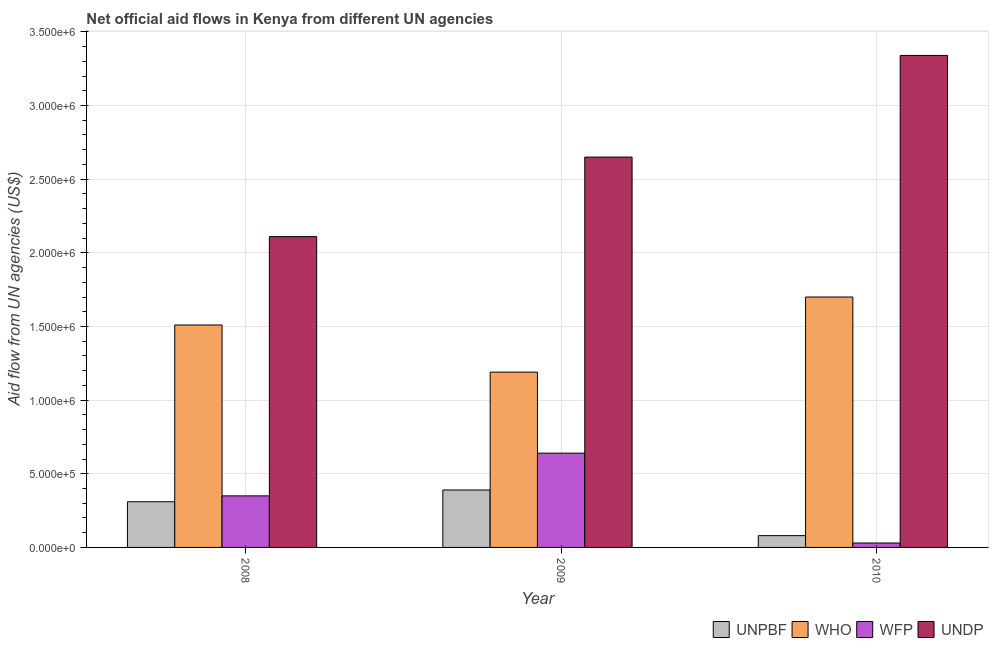How many different coloured bars are there?
Keep it short and to the point. 4. How many groups of bars are there?
Provide a short and direct response. 3. Are the number of bars per tick equal to the number of legend labels?
Make the answer very short. Yes. Are the number of bars on each tick of the X-axis equal?
Ensure brevity in your answer.  Yes. What is the amount of aid given by unpbf in 2010?
Provide a succinct answer. 8.00e+04. Across all years, what is the maximum amount of aid given by wfp?
Your response must be concise. 6.40e+05. Across all years, what is the minimum amount of aid given by unpbf?
Ensure brevity in your answer.  8.00e+04. In which year was the amount of aid given by unpbf minimum?
Your answer should be compact. 2010. What is the total amount of aid given by who in the graph?
Provide a succinct answer. 4.40e+06. What is the difference between the amount of aid given by wfp in 2009 and that in 2010?
Offer a terse response. 6.10e+05. What is the difference between the amount of aid given by who in 2008 and the amount of aid given by wfp in 2010?
Provide a short and direct response. -1.90e+05. What is the average amount of aid given by wfp per year?
Provide a succinct answer. 3.40e+05. In how many years, is the amount of aid given by who greater than 3100000 US$?
Offer a very short reply. 0. What is the ratio of the amount of aid given by undp in 2009 to that in 2010?
Offer a terse response. 0.79. What is the difference between the highest and the lowest amount of aid given by unpbf?
Your answer should be compact. 3.10e+05. What does the 3rd bar from the left in 2010 represents?
Give a very brief answer. WFP. What does the 3rd bar from the right in 2010 represents?
Provide a succinct answer. WHO. Is it the case that in every year, the sum of the amount of aid given by unpbf and amount of aid given by who is greater than the amount of aid given by wfp?
Offer a very short reply. Yes. What is the difference between two consecutive major ticks on the Y-axis?
Provide a short and direct response. 5.00e+05. Are the values on the major ticks of Y-axis written in scientific E-notation?
Your answer should be very brief. Yes. Where does the legend appear in the graph?
Give a very brief answer. Bottom right. How are the legend labels stacked?
Ensure brevity in your answer.  Horizontal. What is the title of the graph?
Give a very brief answer. Net official aid flows in Kenya from different UN agencies. What is the label or title of the Y-axis?
Your response must be concise. Aid flow from UN agencies (US$). What is the Aid flow from UN agencies (US$) of WHO in 2008?
Offer a terse response. 1.51e+06. What is the Aid flow from UN agencies (US$) in UNDP in 2008?
Ensure brevity in your answer.  2.11e+06. What is the Aid flow from UN agencies (US$) in WHO in 2009?
Your answer should be compact. 1.19e+06. What is the Aid flow from UN agencies (US$) of WFP in 2009?
Provide a succinct answer. 6.40e+05. What is the Aid flow from UN agencies (US$) in UNDP in 2009?
Offer a very short reply. 2.65e+06. What is the Aid flow from UN agencies (US$) of UNPBF in 2010?
Your response must be concise. 8.00e+04. What is the Aid flow from UN agencies (US$) of WHO in 2010?
Provide a short and direct response. 1.70e+06. What is the Aid flow from UN agencies (US$) in UNDP in 2010?
Your answer should be compact. 3.34e+06. Across all years, what is the maximum Aid flow from UN agencies (US$) in UNPBF?
Your answer should be very brief. 3.90e+05. Across all years, what is the maximum Aid flow from UN agencies (US$) of WHO?
Offer a terse response. 1.70e+06. Across all years, what is the maximum Aid flow from UN agencies (US$) in WFP?
Make the answer very short. 6.40e+05. Across all years, what is the maximum Aid flow from UN agencies (US$) of UNDP?
Your response must be concise. 3.34e+06. Across all years, what is the minimum Aid flow from UN agencies (US$) in UNPBF?
Offer a terse response. 8.00e+04. Across all years, what is the minimum Aid flow from UN agencies (US$) of WHO?
Offer a terse response. 1.19e+06. Across all years, what is the minimum Aid flow from UN agencies (US$) of UNDP?
Your response must be concise. 2.11e+06. What is the total Aid flow from UN agencies (US$) in UNPBF in the graph?
Give a very brief answer. 7.80e+05. What is the total Aid flow from UN agencies (US$) of WHO in the graph?
Make the answer very short. 4.40e+06. What is the total Aid flow from UN agencies (US$) in WFP in the graph?
Provide a short and direct response. 1.02e+06. What is the total Aid flow from UN agencies (US$) in UNDP in the graph?
Give a very brief answer. 8.10e+06. What is the difference between the Aid flow from UN agencies (US$) in UNPBF in 2008 and that in 2009?
Make the answer very short. -8.00e+04. What is the difference between the Aid flow from UN agencies (US$) in WHO in 2008 and that in 2009?
Make the answer very short. 3.20e+05. What is the difference between the Aid flow from UN agencies (US$) in UNDP in 2008 and that in 2009?
Provide a short and direct response. -5.40e+05. What is the difference between the Aid flow from UN agencies (US$) of UNPBF in 2008 and that in 2010?
Provide a short and direct response. 2.30e+05. What is the difference between the Aid flow from UN agencies (US$) in UNDP in 2008 and that in 2010?
Provide a short and direct response. -1.23e+06. What is the difference between the Aid flow from UN agencies (US$) of UNPBF in 2009 and that in 2010?
Keep it short and to the point. 3.10e+05. What is the difference between the Aid flow from UN agencies (US$) of WHO in 2009 and that in 2010?
Your response must be concise. -5.10e+05. What is the difference between the Aid flow from UN agencies (US$) in WFP in 2009 and that in 2010?
Provide a succinct answer. 6.10e+05. What is the difference between the Aid flow from UN agencies (US$) in UNDP in 2009 and that in 2010?
Provide a succinct answer. -6.90e+05. What is the difference between the Aid flow from UN agencies (US$) of UNPBF in 2008 and the Aid flow from UN agencies (US$) of WHO in 2009?
Ensure brevity in your answer.  -8.80e+05. What is the difference between the Aid flow from UN agencies (US$) in UNPBF in 2008 and the Aid flow from UN agencies (US$) in WFP in 2009?
Your answer should be compact. -3.30e+05. What is the difference between the Aid flow from UN agencies (US$) of UNPBF in 2008 and the Aid flow from UN agencies (US$) of UNDP in 2009?
Provide a succinct answer. -2.34e+06. What is the difference between the Aid flow from UN agencies (US$) in WHO in 2008 and the Aid flow from UN agencies (US$) in WFP in 2009?
Make the answer very short. 8.70e+05. What is the difference between the Aid flow from UN agencies (US$) of WHO in 2008 and the Aid flow from UN agencies (US$) of UNDP in 2009?
Provide a short and direct response. -1.14e+06. What is the difference between the Aid flow from UN agencies (US$) in WFP in 2008 and the Aid flow from UN agencies (US$) in UNDP in 2009?
Your response must be concise. -2.30e+06. What is the difference between the Aid flow from UN agencies (US$) in UNPBF in 2008 and the Aid flow from UN agencies (US$) in WHO in 2010?
Provide a short and direct response. -1.39e+06. What is the difference between the Aid flow from UN agencies (US$) of UNPBF in 2008 and the Aid flow from UN agencies (US$) of WFP in 2010?
Offer a very short reply. 2.80e+05. What is the difference between the Aid flow from UN agencies (US$) of UNPBF in 2008 and the Aid flow from UN agencies (US$) of UNDP in 2010?
Keep it short and to the point. -3.03e+06. What is the difference between the Aid flow from UN agencies (US$) in WHO in 2008 and the Aid flow from UN agencies (US$) in WFP in 2010?
Provide a succinct answer. 1.48e+06. What is the difference between the Aid flow from UN agencies (US$) in WHO in 2008 and the Aid flow from UN agencies (US$) in UNDP in 2010?
Offer a very short reply. -1.83e+06. What is the difference between the Aid flow from UN agencies (US$) of WFP in 2008 and the Aid flow from UN agencies (US$) of UNDP in 2010?
Your answer should be very brief. -2.99e+06. What is the difference between the Aid flow from UN agencies (US$) in UNPBF in 2009 and the Aid flow from UN agencies (US$) in WHO in 2010?
Offer a terse response. -1.31e+06. What is the difference between the Aid flow from UN agencies (US$) in UNPBF in 2009 and the Aid flow from UN agencies (US$) in UNDP in 2010?
Provide a succinct answer. -2.95e+06. What is the difference between the Aid flow from UN agencies (US$) of WHO in 2009 and the Aid flow from UN agencies (US$) of WFP in 2010?
Your answer should be compact. 1.16e+06. What is the difference between the Aid flow from UN agencies (US$) in WHO in 2009 and the Aid flow from UN agencies (US$) in UNDP in 2010?
Offer a terse response. -2.15e+06. What is the difference between the Aid flow from UN agencies (US$) of WFP in 2009 and the Aid flow from UN agencies (US$) of UNDP in 2010?
Ensure brevity in your answer.  -2.70e+06. What is the average Aid flow from UN agencies (US$) in UNPBF per year?
Ensure brevity in your answer.  2.60e+05. What is the average Aid flow from UN agencies (US$) of WHO per year?
Offer a very short reply. 1.47e+06. What is the average Aid flow from UN agencies (US$) of WFP per year?
Make the answer very short. 3.40e+05. What is the average Aid flow from UN agencies (US$) of UNDP per year?
Keep it short and to the point. 2.70e+06. In the year 2008, what is the difference between the Aid flow from UN agencies (US$) in UNPBF and Aid flow from UN agencies (US$) in WHO?
Provide a succinct answer. -1.20e+06. In the year 2008, what is the difference between the Aid flow from UN agencies (US$) of UNPBF and Aid flow from UN agencies (US$) of UNDP?
Offer a very short reply. -1.80e+06. In the year 2008, what is the difference between the Aid flow from UN agencies (US$) of WHO and Aid flow from UN agencies (US$) of WFP?
Ensure brevity in your answer.  1.16e+06. In the year 2008, what is the difference between the Aid flow from UN agencies (US$) of WHO and Aid flow from UN agencies (US$) of UNDP?
Keep it short and to the point. -6.00e+05. In the year 2008, what is the difference between the Aid flow from UN agencies (US$) of WFP and Aid flow from UN agencies (US$) of UNDP?
Provide a short and direct response. -1.76e+06. In the year 2009, what is the difference between the Aid flow from UN agencies (US$) of UNPBF and Aid flow from UN agencies (US$) of WHO?
Offer a very short reply. -8.00e+05. In the year 2009, what is the difference between the Aid flow from UN agencies (US$) in UNPBF and Aid flow from UN agencies (US$) in UNDP?
Provide a short and direct response. -2.26e+06. In the year 2009, what is the difference between the Aid flow from UN agencies (US$) in WHO and Aid flow from UN agencies (US$) in UNDP?
Keep it short and to the point. -1.46e+06. In the year 2009, what is the difference between the Aid flow from UN agencies (US$) of WFP and Aid flow from UN agencies (US$) of UNDP?
Provide a succinct answer. -2.01e+06. In the year 2010, what is the difference between the Aid flow from UN agencies (US$) in UNPBF and Aid flow from UN agencies (US$) in WHO?
Give a very brief answer. -1.62e+06. In the year 2010, what is the difference between the Aid flow from UN agencies (US$) of UNPBF and Aid flow from UN agencies (US$) of UNDP?
Keep it short and to the point. -3.26e+06. In the year 2010, what is the difference between the Aid flow from UN agencies (US$) of WHO and Aid flow from UN agencies (US$) of WFP?
Your answer should be very brief. 1.67e+06. In the year 2010, what is the difference between the Aid flow from UN agencies (US$) of WHO and Aid flow from UN agencies (US$) of UNDP?
Ensure brevity in your answer.  -1.64e+06. In the year 2010, what is the difference between the Aid flow from UN agencies (US$) of WFP and Aid flow from UN agencies (US$) of UNDP?
Ensure brevity in your answer.  -3.31e+06. What is the ratio of the Aid flow from UN agencies (US$) in UNPBF in 2008 to that in 2009?
Make the answer very short. 0.79. What is the ratio of the Aid flow from UN agencies (US$) of WHO in 2008 to that in 2009?
Offer a very short reply. 1.27. What is the ratio of the Aid flow from UN agencies (US$) of WFP in 2008 to that in 2009?
Your answer should be compact. 0.55. What is the ratio of the Aid flow from UN agencies (US$) of UNDP in 2008 to that in 2009?
Ensure brevity in your answer.  0.8. What is the ratio of the Aid flow from UN agencies (US$) of UNPBF in 2008 to that in 2010?
Keep it short and to the point. 3.88. What is the ratio of the Aid flow from UN agencies (US$) in WHO in 2008 to that in 2010?
Your answer should be compact. 0.89. What is the ratio of the Aid flow from UN agencies (US$) in WFP in 2008 to that in 2010?
Ensure brevity in your answer.  11.67. What is the ratio of the Aid flow from UN agencies (US$) of UNDP in 2008 to that in 2010?
Your answer should be compact. 0.63. What is the ratio of the Aid flow from UN agencies (US$) of UNPBF in 2009 to that in 2010?
Ensure brevity in your answer.  4.88. What is the ratio of the Aid flow from UN agencies (US$) of WHO in 2009 to that in 2010?
Ensure brevity in your answer.  0.7. What is the ratio of the Aid flow from UN agencies (US$) in WFP in 2009 to that in 2010?
Provide a succinct answer. 21.33. What is the ratio of the Aid flow from UN agencies (US$) in UNDP in 2009 to that in 2010?
Your response must be concise. 0.79. What is the difference between the highest and the second highest Aid flow from UN agencies (US$) in UNPBF?
Offer a terse response. 8.00e+04. What is the difference between the highest and the second highest Aid flow from UN agencies (US$) in UNDP?
Make the answer very short. 6.90e+05. What is the difference between the highest and the lowest Aid flow from UN agencies (US$) of UNPBF?
Ensure brevity in your answer.  3.10e+05. What is the difference between the highest and the lowest Aid flow from UN agencies (US$) of WHO?
Make the answer very short. 5.10e+05. What is the difference between the highest and the lowest Aid flow from UN agencies (US$) of UNDP?
Your response must be concise. 1.23e+06. 